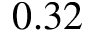<formula> <loc_0><loc_0><loc_500><loc_500>0 . 3 2</formula> 